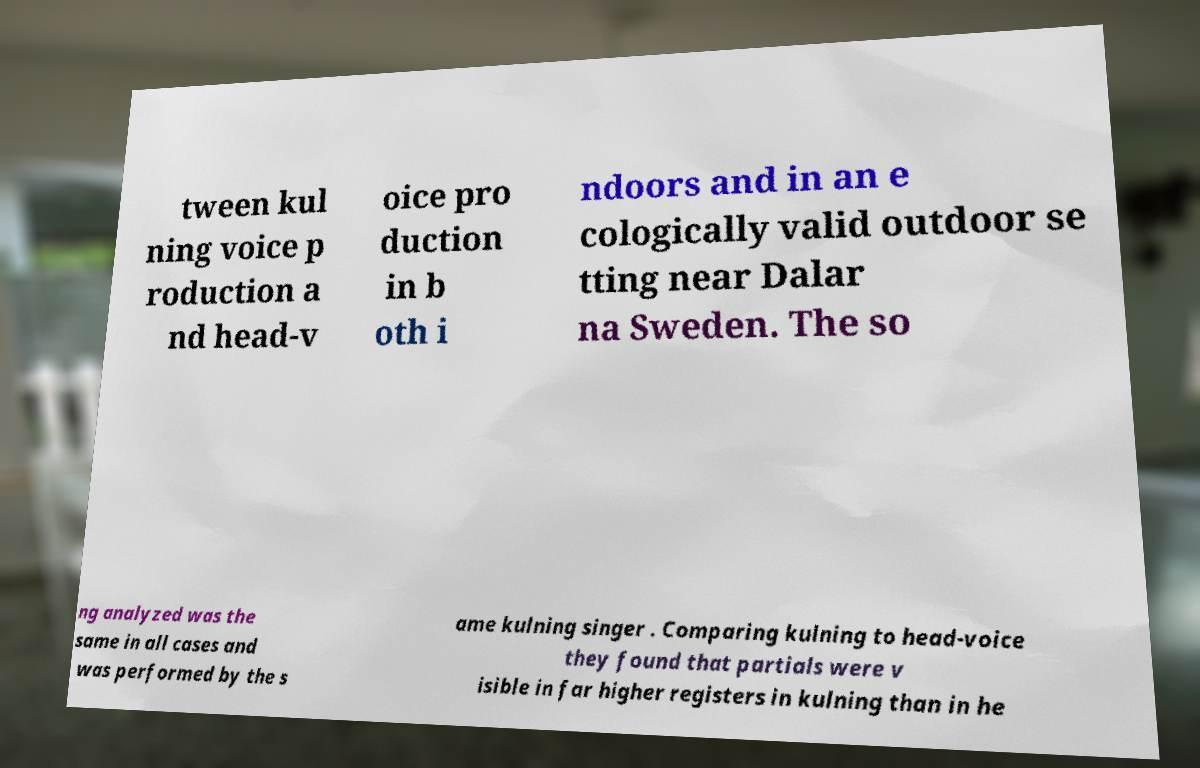What messages or text are displayed in this image? I need them in a readable, typed format. tween kul ning voice p roduction a nd head-v oice pro duction in b oth i ndoors and in an e cologically valid outdoor se tting near Dalar na Sweden. The so ng analyzed was the same in all cases and was performed by the s ame kulning singer . Comparing kulning to head-voice they found that partials were v isible in far higher registers in kulning than in he 